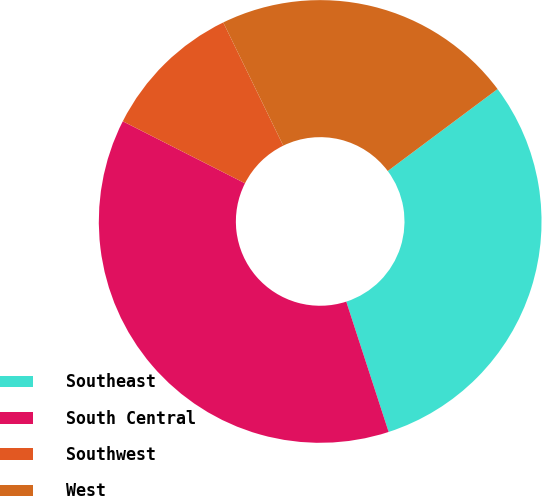<chart> <loc_0><loc_0><loc_500><loc_500><pie_chart><fcel>Southeast<fcel>South Central<fcel>Southwest<fcel>West<nl><fcel>30.2%<fcel>37.48%<fcel>10.31%<fcel>22.01%<nl></chart> 